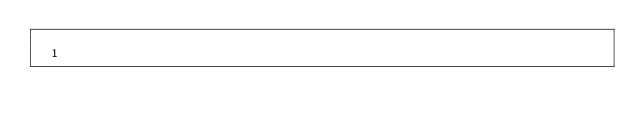<code> <loc_0><loc_0><loc_500><loc_500><_Scala_>
  1
</code> 